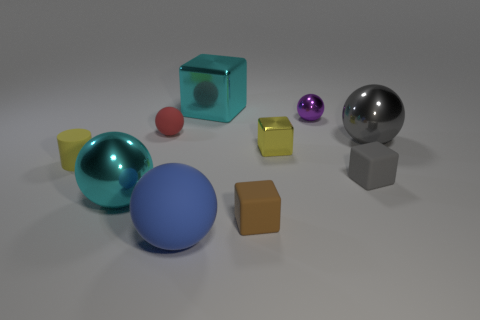Subtract all tiny metal spheres. How many spheres are left? 4 Subtract 2 balls. How many balls are left? 3 Add 9 small metallic balls. How many small metallic balls exist? 10 Subtract all purple spheres. How many spheres are left? 4 Subtract 0 purple cylinders. How many objects are left? 10 Subtract all blocks. How many objects are left? 6 Subtract all brown cubes. Subtract all purple cylinders. How many cubes are left? 3 Subtract all blue cylinders. How many green cubes are left? 0 Subtract all big blue matte objects. Subtract all big cyan cubes. How many objects are left? 8 Add 6 large cyan spheres. How many large cyan spheres are left? 7 